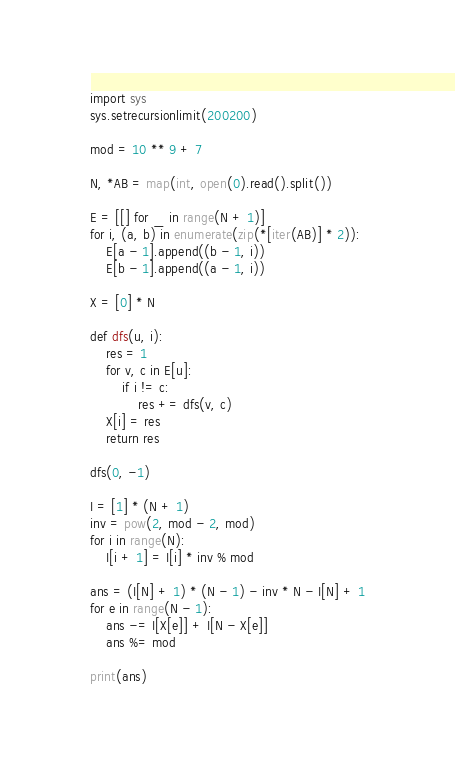Convert code to text. <code><loc_0><loc_0><loc_500><loc_500><_Python_>import sys
sys.setrecursionlimit(200200)

mod = 10 ** 9 + 7

N, *AB = map(int, open(0).read().split())

E = [[] for _ in range(N + 1)]
for i, (a, b) in enumerate(zip(*[iter(AB)] * 2)):
    E[a - 1].append((b - 1, i))
    E[b - 1].append((a - 1, i))

X = [0] * N

def dfs(u, i):
    res = 1
    for v, c in E[u]:
        if i != c:
            res += dfs(v, c)
    X[i] = res
    return res

dfs(0, -1)

I = [1] * (N + 1)
inv = pow(2, mod - 2, mod)
for i in range(N):
    I[i + 1] = I[i] * inv % mod

ans = (I[N] + 1) * (N - 1) - inv * N - I[N] + 1
for e in range(N - 1):
    ans -= I[X[e]] + I[N - X[e]]
    ans %= mod

print(ans)</code> 